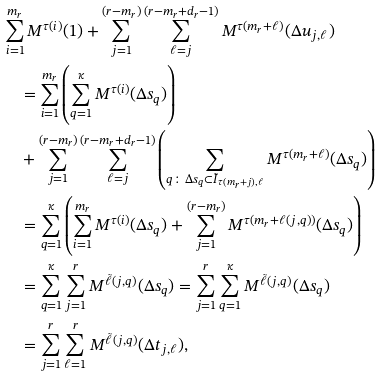<formula> <loc_0><loc_0><loc_500><loc_500>& \sum _ { i = 1 } ^ { m _ { r } } M ^ { \tau ( i ) } ( 1 ) + \sum _ { j = 1 } ^ { ( r - m _ { r } ) } \sum _ { \ell = j } ^ { ( r - m _ { r } + d _ { r } - 1 ) } M ^ { \tau ( m _ { r } + \ell ) } ( \Delta u _ { j , \ell } ) \\ & \quad = \sum _ { i = 1 } ^ { m _ { r } } \left ( \sum _ { q = 1 } ^ { \kappa } M ^ { \tau ( i ) } ( \Delta s _ { q } ) \right ) \\ & \quad + \sum _ { j = 1 } ^ { ( r - m _ { r } ) } \sum _ { \ell = j } ^ { ( r - m _ { r } + d _ { r } - 1 ) } \left ( \sum _ { q \colon \Delta s _ { q } \subset \tilde { I } _ { \tau ( m _ { r } + j ) , \ell } } M ^ { \tau ( m _ { r } + \ell ) } ( \Delta s _ { q } ) \right ) \\ & \quad = \sum _ { q = 1 } ^ { \kappa } \left ( \sum _ { i = 1 } ^ { m _ { r } } M ^ { \tau ( i ) } ( \Delta s _ { q } ) + \sum _ { j = 1 } ^ { ( r - m _ { r } ) } M ^ { \tau ( m _ { r } + \ell ( j , q ) ) } ( \Delta s _ { q } ) \right ) \\ & \quad = \sum _ { q = 1 } ^ { \kappa } \sum _ { j = 1 } ^ { r } M ^ { \tilde { \ell } ( j , q ) } ( \Delta s _ { q } ) = \sum _ { j = 1 } ^ { r } \sum _ { q = 1 } ^ { \kappa } M ^ { \tilde { \ell } ( j , q ) } ( \Delta s _ { q } ) \\ & \quad = \sum _ { j = 1 } ^ { r } \sum _ { \ell = 1 } ^ { r } M ^ { \tilde { \ell } ( j , q ) } ( \Delta t _ { j , \ell } ) ,</formula> 